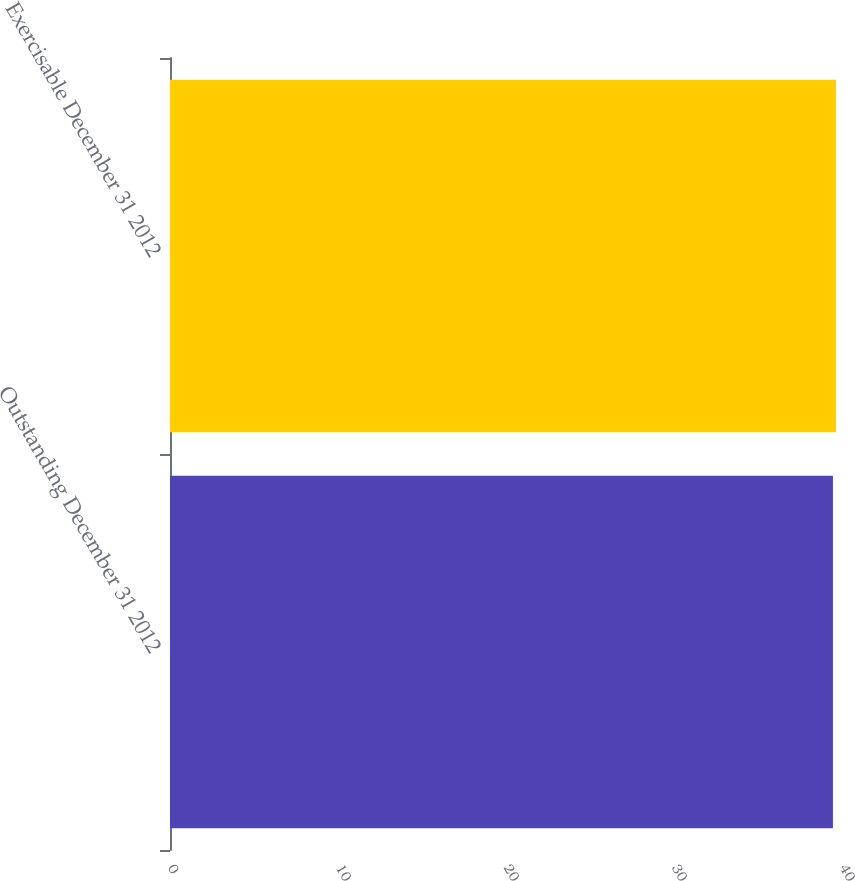Convert chart to OTSL. <chart><loc_0><loc_0><loc_500><loc_500><bar_chart><fcel>Outstanding December 31 2012<fcel>Exercisable December 31 2012<nl><fcel>39.46<fcel>39.64<nl></chart> 